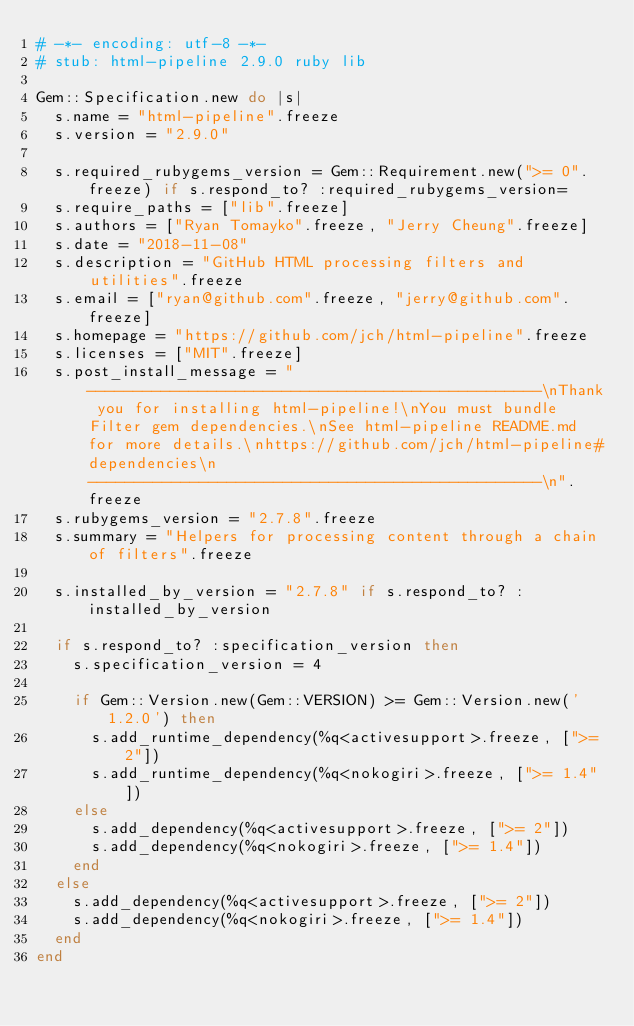Convert code to text. <code><loc_0><loc_0><loc_500><loc_500><_Ruby_># -*- encoding: utf-8 -*-
# stub: html-pipeline 2.9.0 ruby lib

Gem::Specification.new do |s|
  s.name = "html-pipeline".freeze
  s.version = "2.9.0"

  s.required_rubygems_version = Gem::Requirement.new(">= 0".freeze) if s.respond_to? :required_rubygems_version=
  s.require_paths = ["lib".freeze]
  s.authors = ["Ryan Tomayko".freeze, "Jerry Cheung".freeze]
  s.date = "2018-11-08"
  s.description = "GitHub HTML processing filters and utilities".freeze
  s.email = ["ryan@github.com".freeze, "jerry@github.com".freeze]
  s.homepage = "https://github.com/jch/html-pipeline".freeze
  s.licenses = ["MIT".freeze]
  s.post_install_message = "-------------------------------------------------\nThank you for installing html-pipeline!\nYou must bundle Filter gem dependencies.\nSee html-pipeline README.md for more details.\nhttps://github.com/jch/html-pipeline#dependencies\n-------------------------------------------------\n".freeze
  s.rubygems_version = "2.7.8".freeze
  s.summary = "Helpers for processing content through a chain of filters".freeze

  s.installed_by_version = "2.7.8" if s.respond_to? :installed_by_version

  if s.respond_to? :specification_version then
    s.specification_version = 4

    if Gem::Version.new(Gem::VERSION) >= Gem::Version.new('1.2.0') then
      s.add_runtime_dependency(%q<activesupport>.freeze, [">= 2"])
      s.add_runtime_dependency(%q<nokogiri>.freeze, [">= 1.4"])
    else
      s.add_dependency(%q<activesupport>.freeze, [">= 2"])
      s.add_dependency(%q<nokogiri>.freeze, [">= 1.4"])
    end
  else
    s.add_dependency(%q<activesupport>.freeze, [">= 2"])
    s.add_dependency(%q<nokogiri>.freeze, [">= 1.4"])
  end
end
</code> 